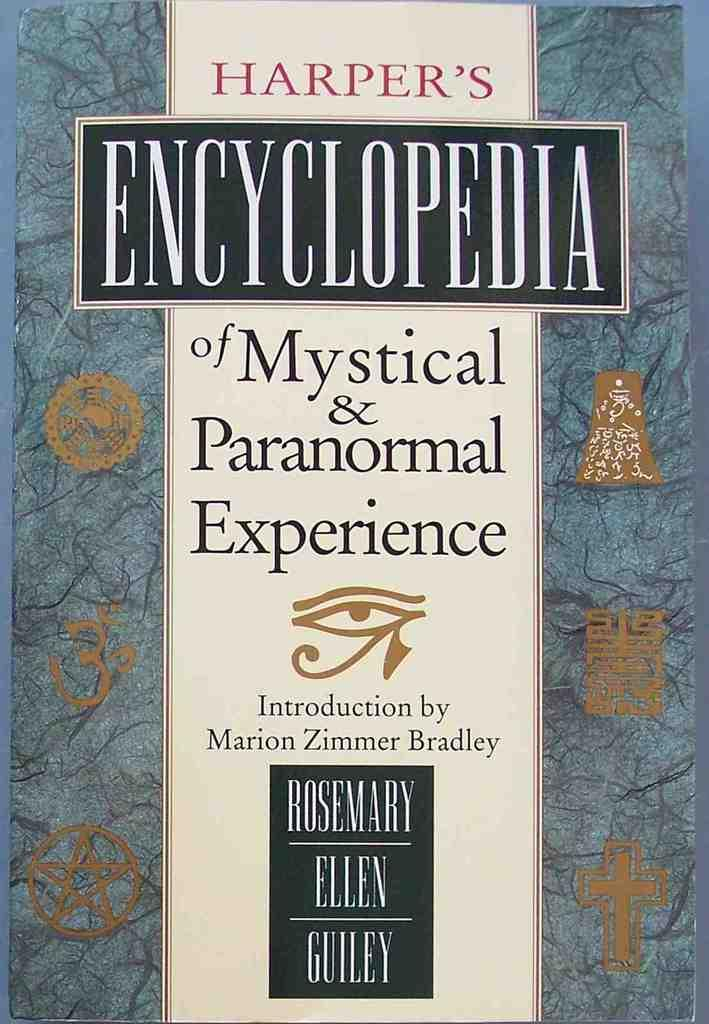<image>
Summarize the visual content of the image. A Harper's Encyclopedia book is embellished with gold symbols on the front 